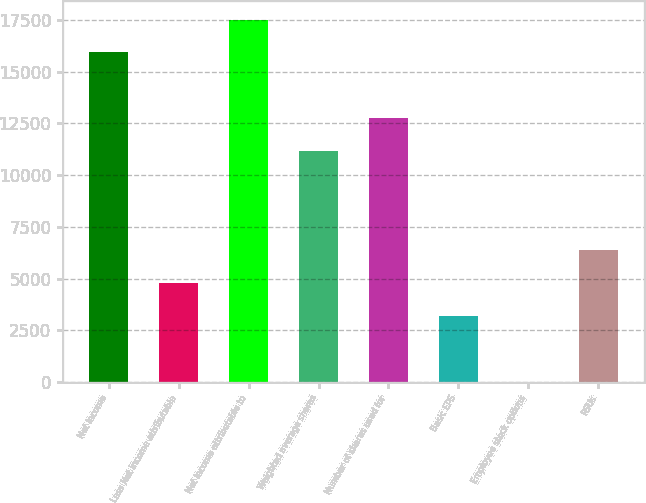Convert chart. <chart><loc_0><loc_0><loc_500><loc_500><bar_chart><fcel>Net income<fcel>Less Net income attributable<fcel>Net income attributable to<fcel>Weighted average shares<fcel>Number of shares used for<fcel>Basic EPS<fcel>Employee stock options<fcel>RSUs<nl><fcel>15934<fcel>4783<fcel>17527<fcel>11155<fcel>12748<fcel>3190<fcel>4<fcel>6376<nl></chart> 